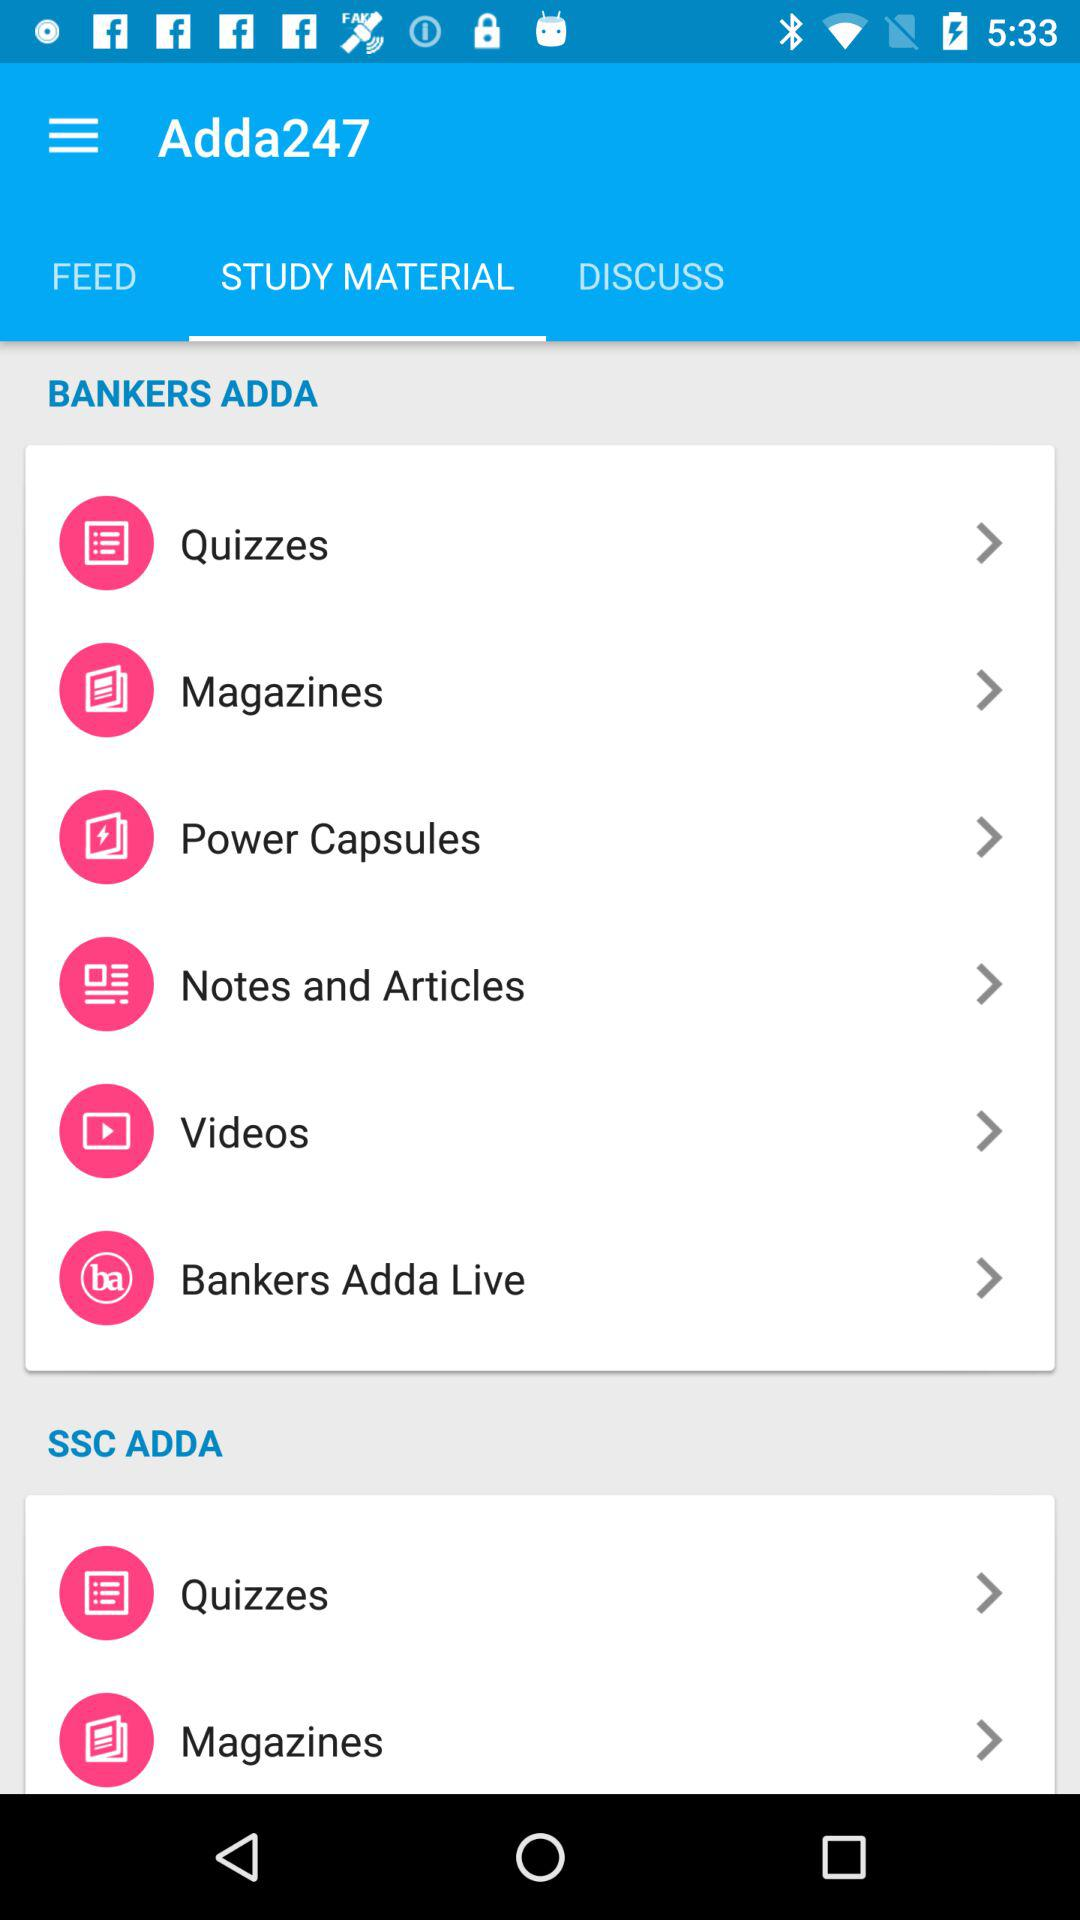How many quizzes are available?
When the provided information is insufficient, respond with <no answer>. <no answer> 